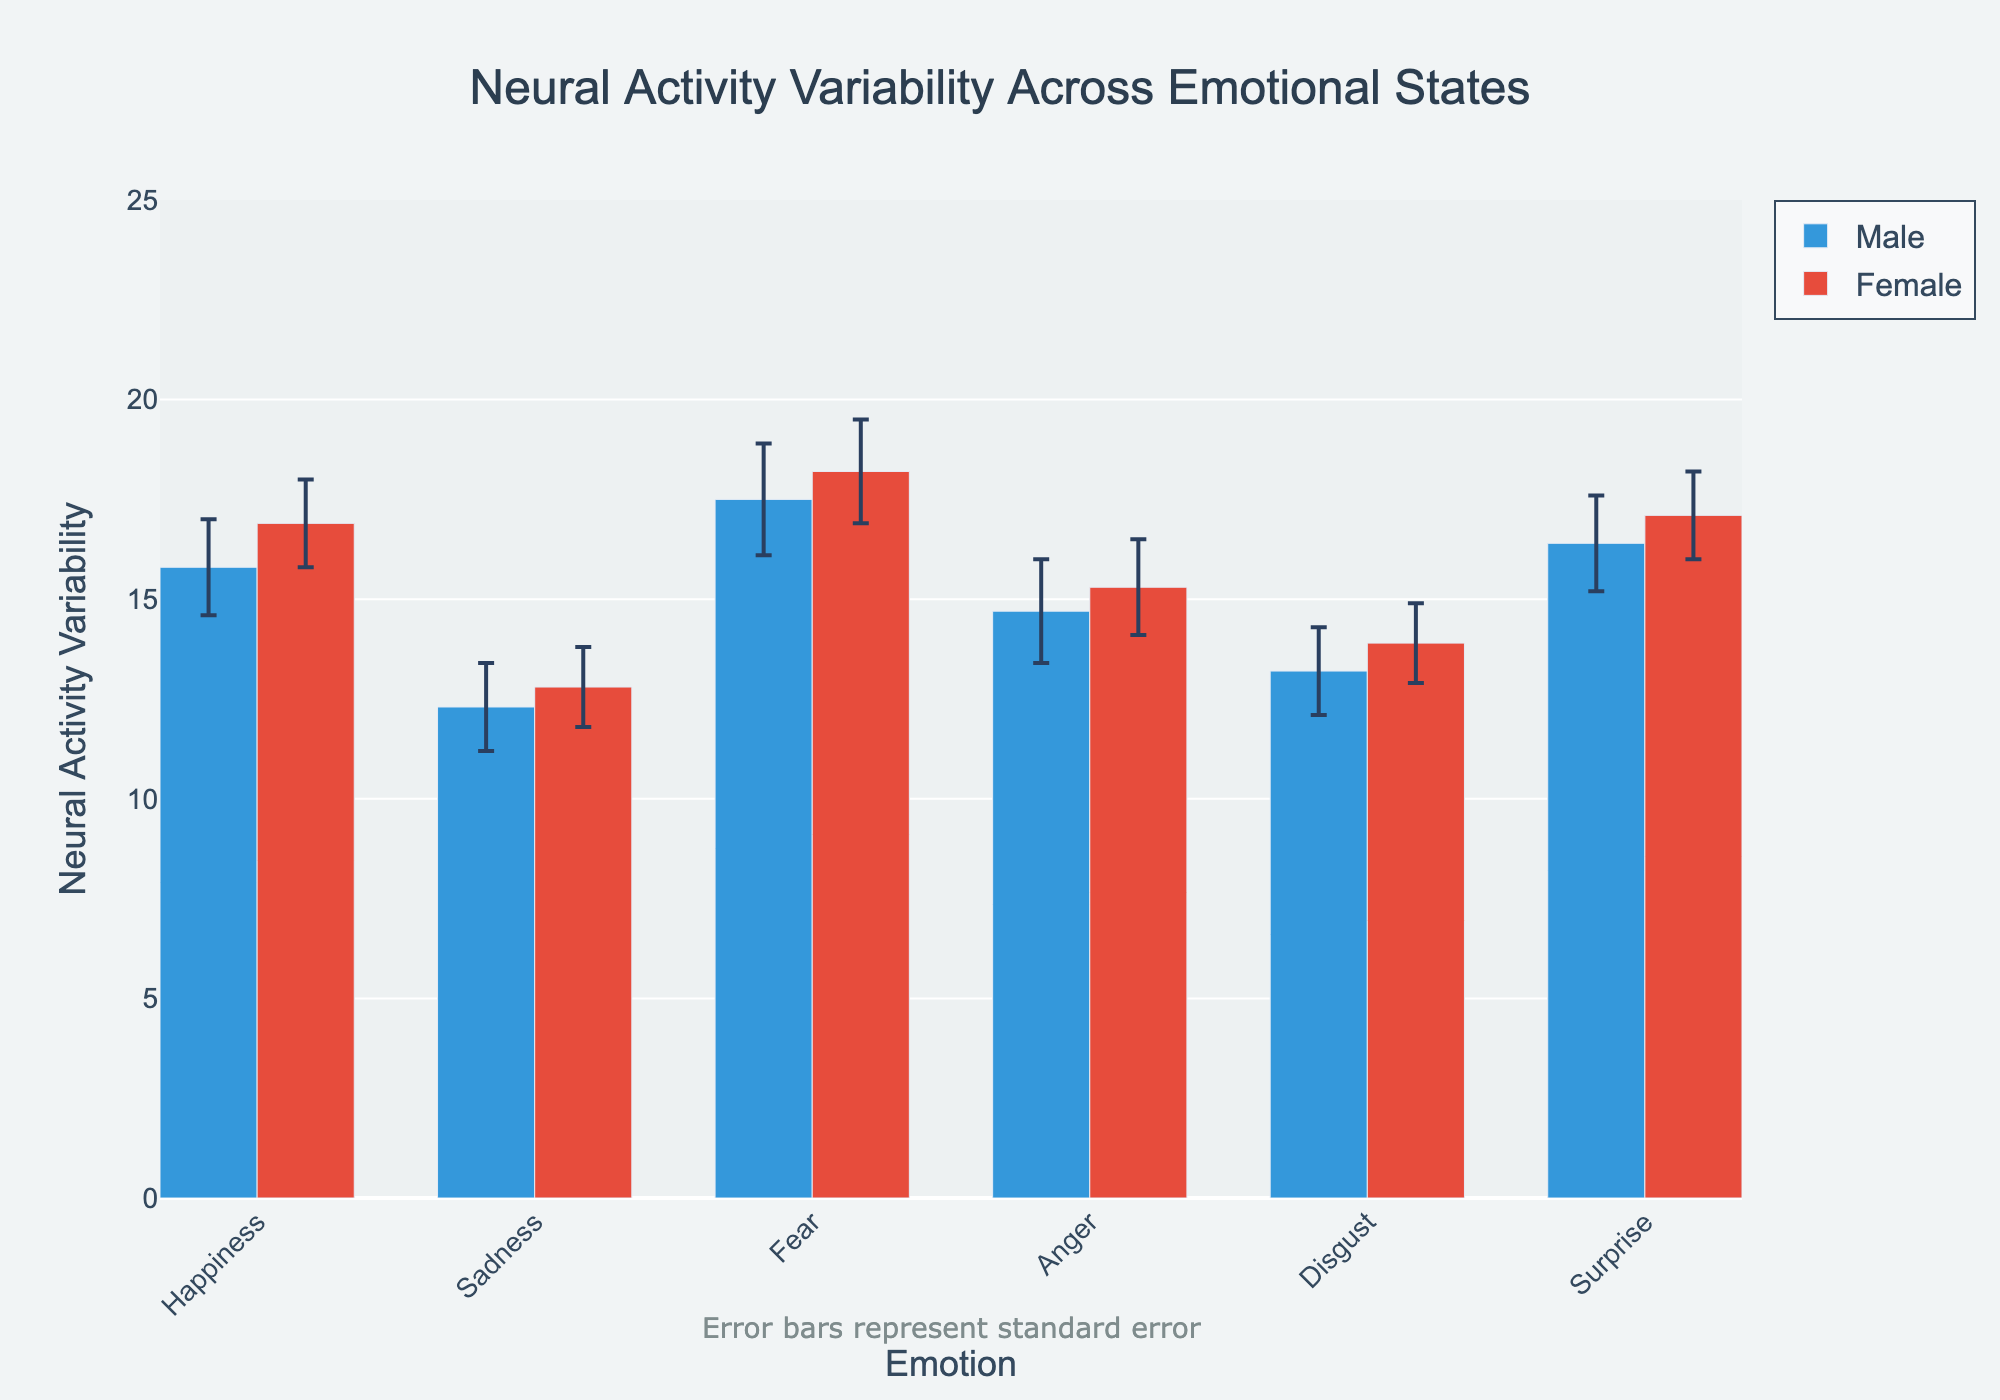What's the title of the figure? The title of the figure is displayed prominently at the top of the chart.
Answer: Neural Activity Variability Across Emotional States Which emotion has the highest neural activity variability for males? Look at the bar heights for males and compare them across all emotions. Fear has the tallest bar.
Answer: Fear Which gender shows higher neural activity variability for the emotion of anger? Compare the heights of the bars representing anger for both males and females. The female bar is taller.
Answer: Female What's the neural activity variability for females experiencing happiness? Identify the bar corresponding to females for the happiness emotion and read its height.
Answer: 16.9 What are the error bars representing? There's an annotation below the figure explaining that error bars represent the standard error.
Answer: Standard error Compare the neural activity variability for males and females experiencing disgust. Which one is higher? Inspect the bars for males and females for the disgust emotion and compare. The female bar is higher.
Answer: Female What's the average neural activity variability for males across all emotions? Sum the neural activity variability values for males across all emotions and divide by the number of emotions (6). (15.8 + 12.3 + 17.5 + 14.7 + 13.2 + 16.4) / 6 = 15. For detailed steps: 90 / 6 = 15.
Answer: 15 For which emotion do females show the highest neural activity variability? Check the highest bar among females for all the emotions. Fear has the tallest bar.
Answer: Fear What is the standard error for males experiencing sadness? Identify the error bar for males in the sadness emotion and read the value.
Answer: 1.1 